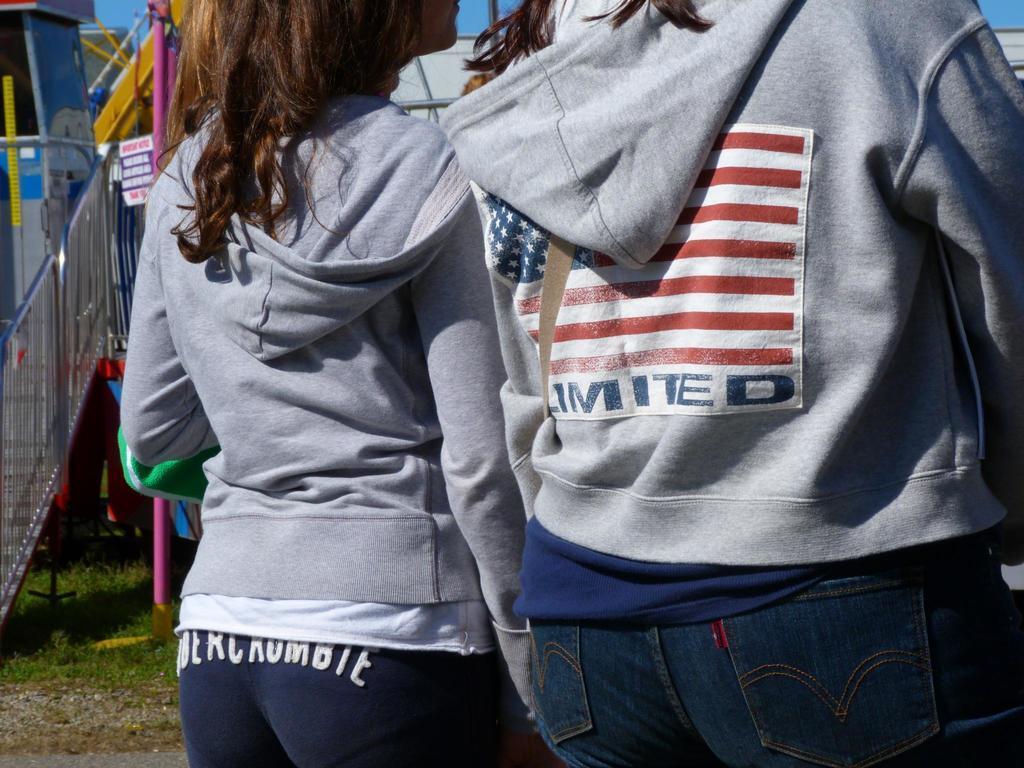How would you summarize this image in a sentence or two? There are two people standing. They wore jerkins and trousers. These are the stairs. I think this is a pole. Here is the grass. 